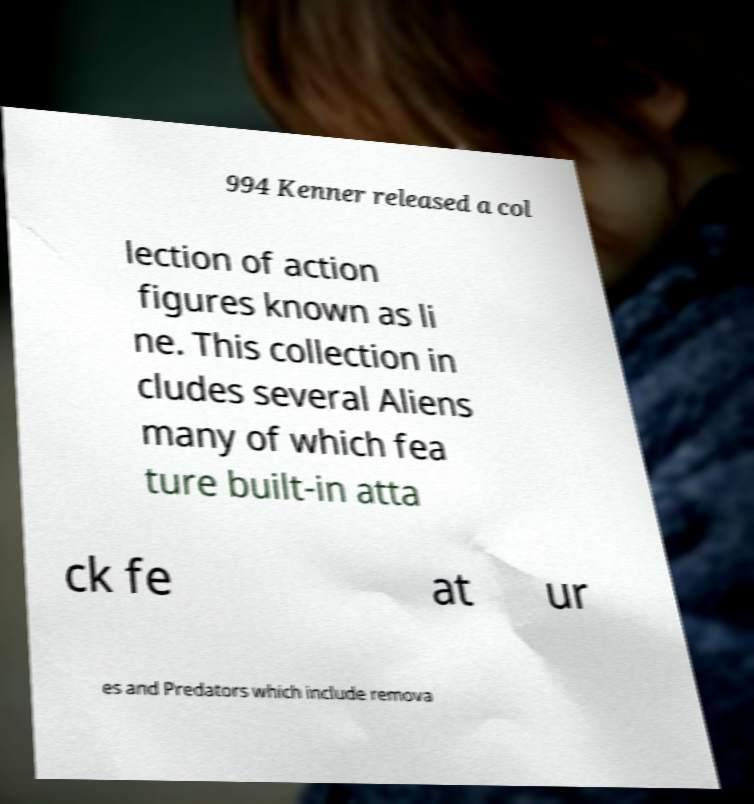For documentation purposes, I need the text within this image transcribed. Could you provide that? 994 Kenner released a col lection of action figures known as li ne. This collection in cludes several Aliens many of which fea ture built-in atta ck fe at ur es and Predators which include remova 